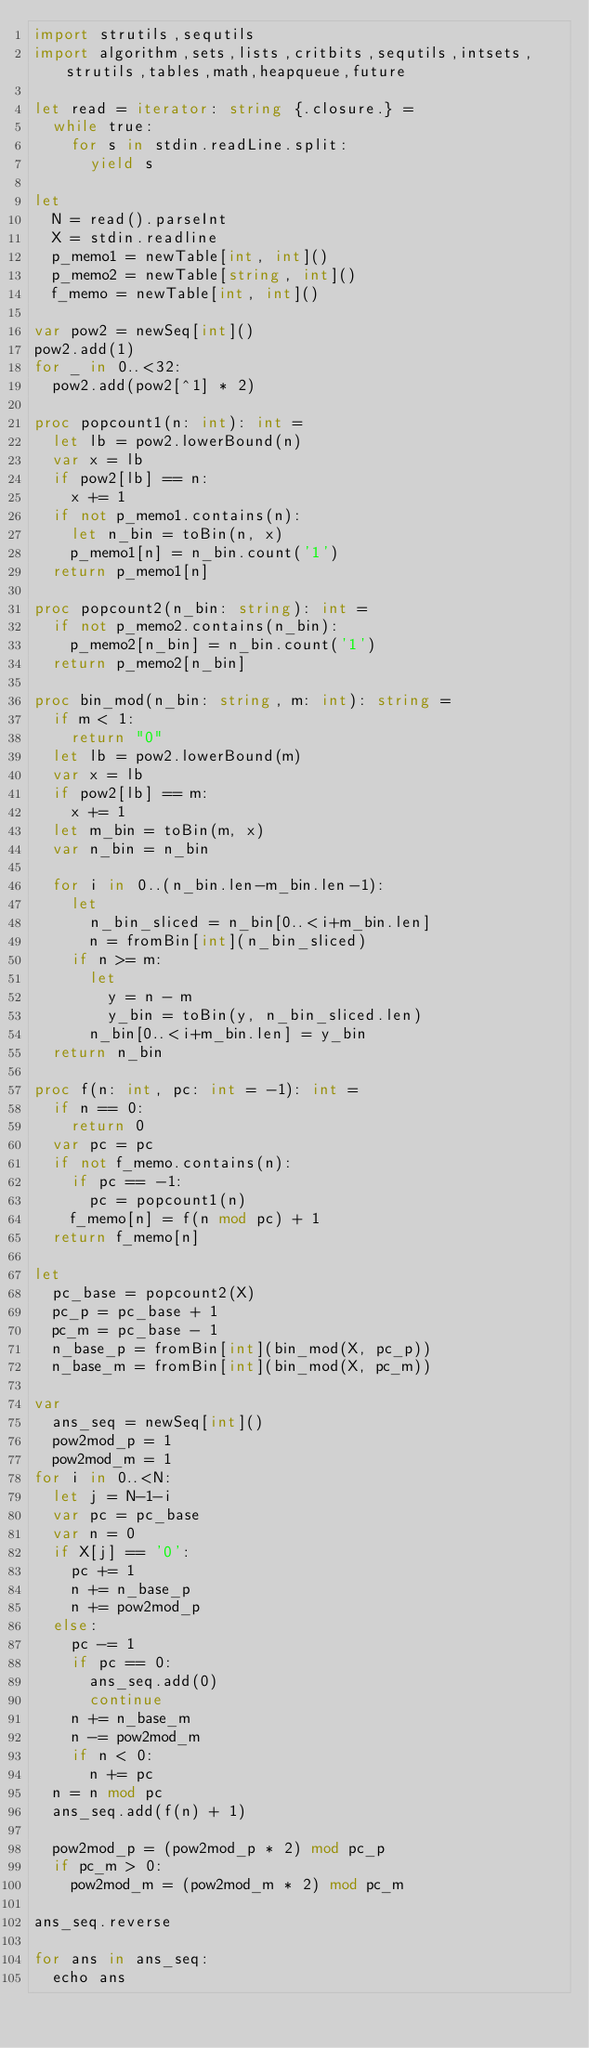Convert code to text. <code><loc_0><loc_0><loc_500><loc_500><_Nim_>import strutils,sequtils
import algorithm,sets,lists,critbits,sequtils,intsets,strutils,tables,math,heapqueue,future

let read = iterator: string {.closure.} =
  while true:
    for s in stdin.readLine.split:
      yield s

let
  N = read().parseInt
  X = stdin.readline
  p_memo1 = newTable[int, int]()
  p_memo2 = newTable[string, int]()
  f_memo = newTable[int, int]()

var pow2 = newSeq[int]()
pow2.add(1)
for _ in 0..<32:
  pow2.add(pow2[^1] * 2)

proc popcount1(n: int): int =
  let lb = pow2.lowerBound(n)
  var x = lb
  if pow2[lb] == n:
    x += 1
  if not p_memo1.contains(n):
    let n_bin = toBin(n, x)
    p_memo1[n] = n_bin.count('1')
  return p_memo1[n]

proc popcount2(n_bin: string): int =
  if not p_memo2.contains(n_bin):
    p_memo2[n_bin] = n_bin.count('1')
  return p_memo2[n_bin]

proc bin_mod(n_bin: string, m: int): string =
  if m < 1:
    return "0"
  let lb = pow2.lowerBound(m)
  var x = lb
  if pow2[lb] == m:
    x += 1
  let m_bin = toBin(m, x)
  var n_bin = n_bin

  for i in 0..(n_bin.len-m_bin.len-1):
    let
      n_bin_sliced = n_bin[0..<i+m_bin.len]
      n = fromBin[int](n_bin_sliced)
    if n >= m:
      let
        y = n - m
        y_bin = toBin(y, n_bin_sliced.len)
      n_bin[0..<i+m_bin.len] = y_bin
  return n_bin

proc f(n: int, pc: int = -1): int =
  if n == 0:
    return 0
  var pc = pc
  if not f_memo.contains(n):
    if pc == -1:
      pc = popcount1(n)
    f_memo[n] = f(n mod pc) + 1
  return f_memo[n]

let
  pc_base = popcount2(X)
  pc_p = pc_base + 1
  pc_m = pc_base - 1
  n_base_p = fromBin[int](bin_mod(X, pc_p))
  n_base_m = fromBin[int](bin_mod(X, pc_m))

var
  ans_seq = newSeq[int]()
  pow2mod_p = 1
  pow2mod_m = 1
for i in 0..<N:
  let j = N-1-i
  var pc = pc_base
  var n = 0
  if X[j] == '0':
    pc += 1
    n += n_base_p
    n += pow2mod_p
  else:
    pc -= 1
    if pc == 0:
      ans_seq.add(0)
      continue
    n += n_base_m
    n -= pow2mod_m
    if n < 0:
      n += pc
  n = n mod pc
  ans_seq.add(f(n) + 1)

  pow2mod_p = (pow2mod_p * 2) mod pc_p
  if pc_m > 0:
    pow2mod_m = (pow2mod_m * 2) mod pc_m

ans_seq.reverse

for ans in ans_seq:
  echo ans
</code> 